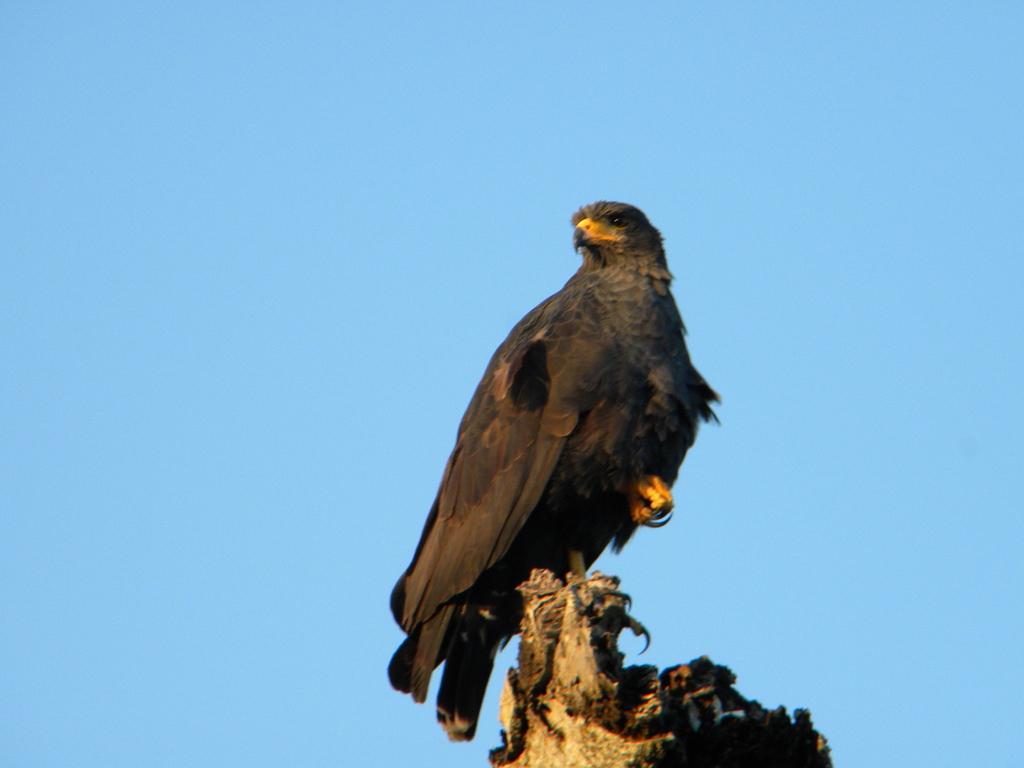How would you summarize this image in a sentence or two? In the image in the center we can see one wood. On the wood,we can see one bird,which is in black color. In the background we can see the sky. 